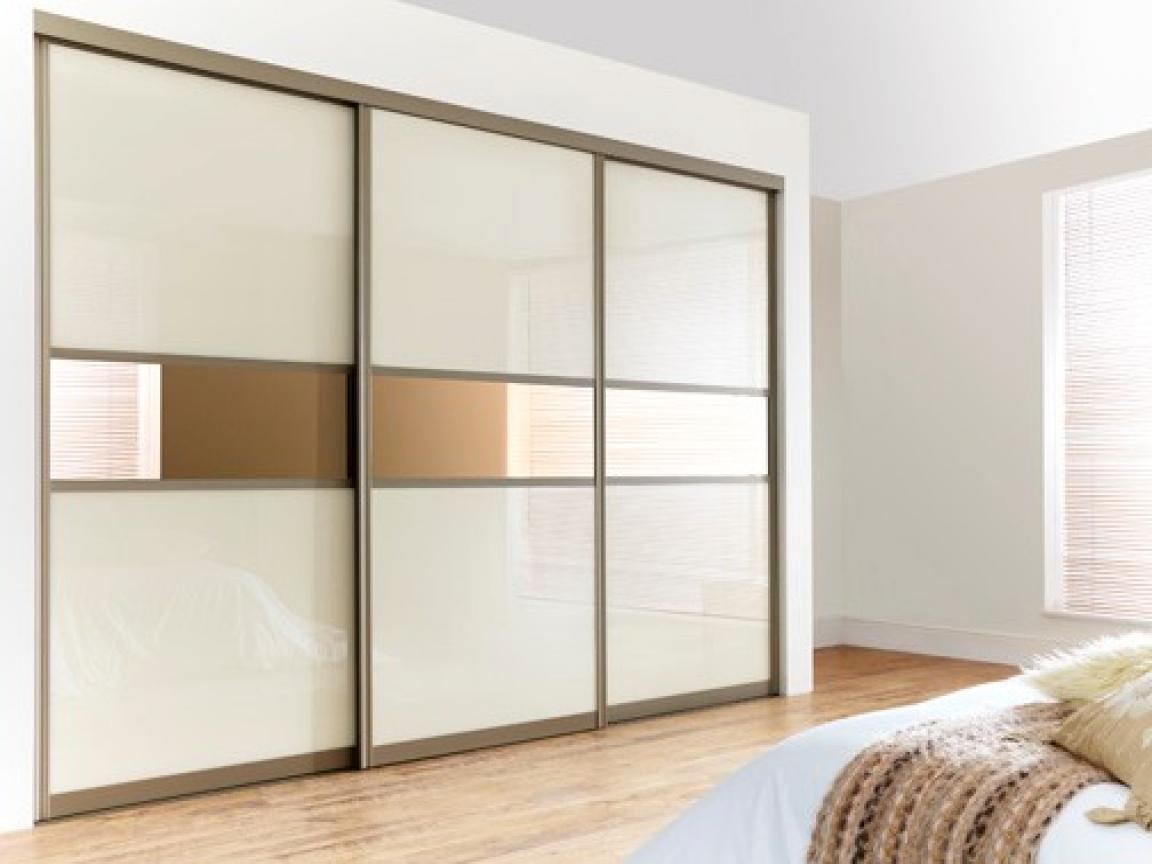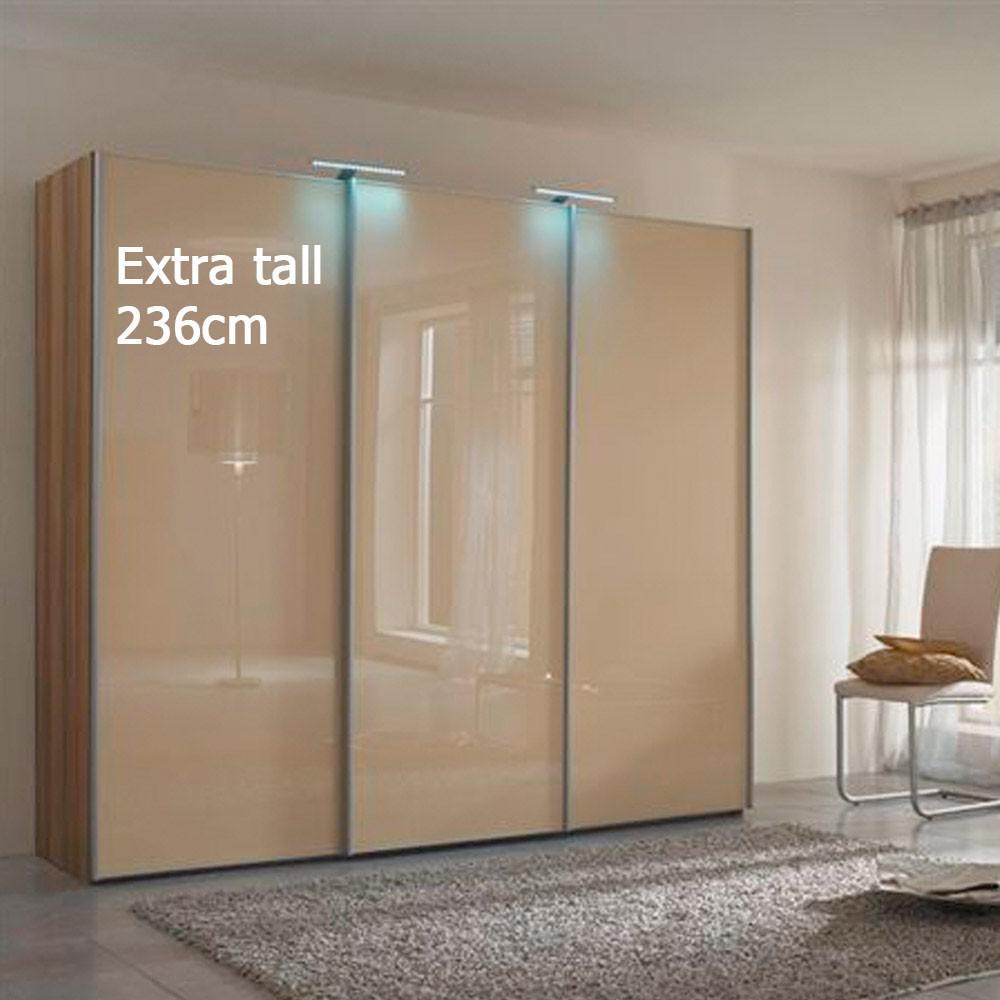The first image is the image on the left, the second image is the image on the right. Examine the images to the left and right. Is the description "There are two closets with glass doors." accurate? Answer yes or no. Yes. 